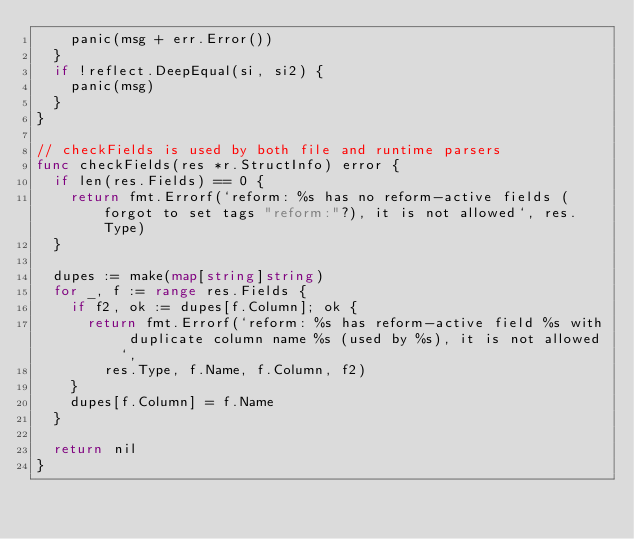<code> <loc_0><loc_0><loc_500><loc_500><_Go_>		panic(msg + err.Error())
	}
	if !reflect.DeepEqual(si, si2) {
		panic(msg)
	}
}

// checkFields is used by both file and runtime parsers
func checkFields(res *r.StructInfo) error {
	if len(res.Fields) == 0 {
		return fmt.Errorf(`reform: %s has no reform-active fields (forgot to set tags "reform:"?), it is not allowed`, res.Type)
	}

	dupes := make(map[string]string)
	for _, f := range res.Fields {
		if f2, ok := dupes[f.Column]; ok {
			return fmt.Errorf(`reform: %s has reform-active field %s with duplicate column name %s (used by %s), it is not allowed`,
				res.Type, f.Name, f.Column, f2)
		}
		dupes[f.Column] = f.Name
	}

	return nil
}
</code> 